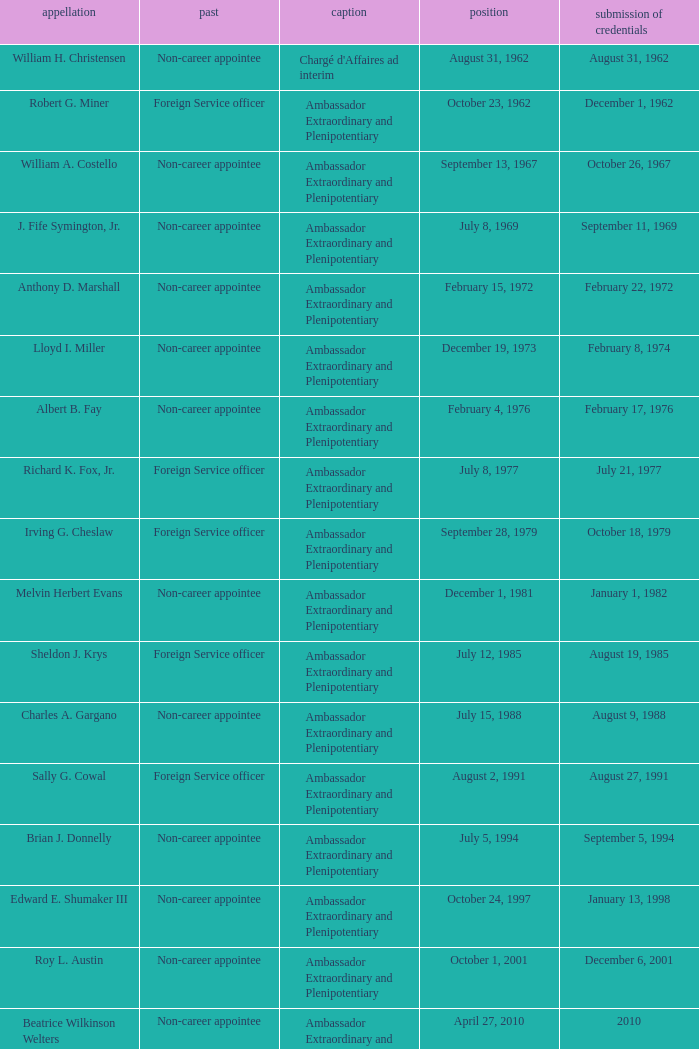Who presented their credentials at an unknown date? Margaret B. Diop. 